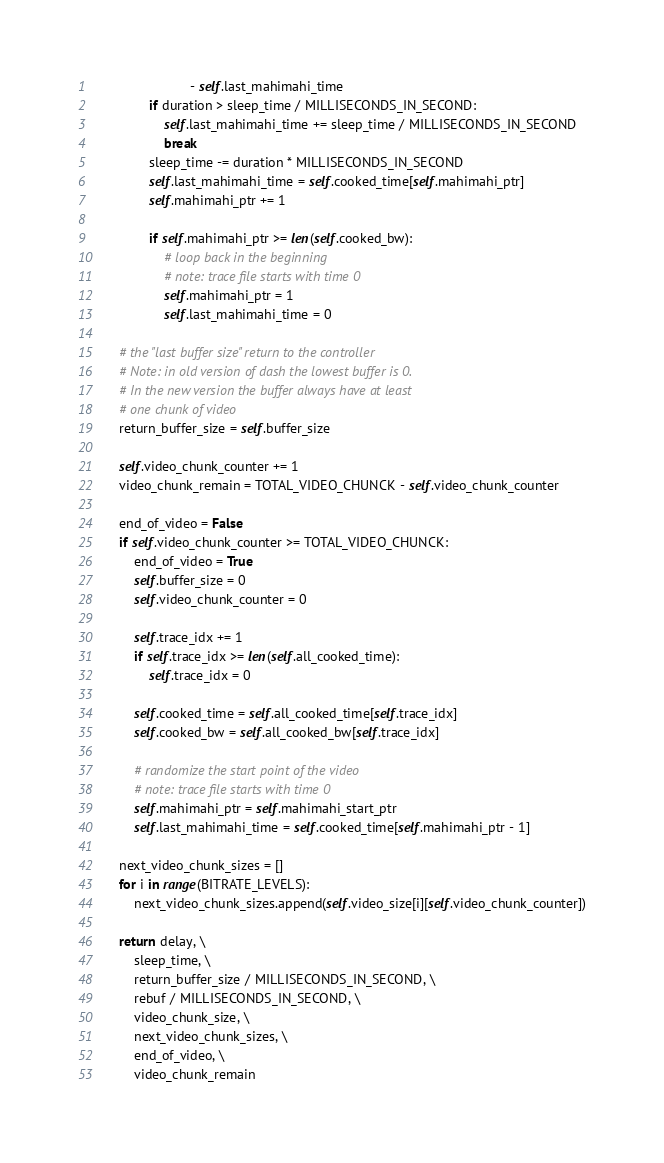Convert code to text. <code><loc_0><loc_0><loc_500><loc_500><_Python_>                           - self.last_mahimahi_time
                if duration > sleep_time / MILLISECONDS_IN_SECOND:
                    self.last_mahimahi_time += sleep_time / MILLISECONDS_IN_SECOND
                    break
                sleep_time -= duration * MILLISECONDS_IN_SECOND
                self.last_mahimahi_time = self.cooked_time[self.mahimahi_ptr]
                self.mahimahi_ptr += 1

                if self.mahimahi_ptr >= len(self.cooked_bw):
                    # loop back in the beginning
                    # note: trace file starts with time 0
                    self.mahimahi_ptr = 1
                    self.last_mahimahi_time = 0

        # the "last buffer size" return to the controller
        # Note: in old version of dash the lowest buffer is 0.
        # In the new version the buffer always have at least
        # one chunk of video
        return_buffer_size = self.buffer_size

        self.video_chunk_counter += 1
        video_chunk_remain = TOTAL_VIDEO_CHUNCK - self.video_chunk_counter

        end_of_video = False
        if self.video_chunk_counter >= TOTAL_VIDEO_CHUNCK:
            end_of_video = True
            self.buffer_size = 0
            self.video_chunk_counter = 0
            
            self.trace_idx += 1
            if self.trace_idx >= len(self.all_cooked_time):
                self.trace_idx = 0            

            self.cooked_time = self.all_cooked_time[self.trace_idx]
            self.cooked_bw = self.all_cooked_bw[self.trace_idx]

            # randomize the start point of the video
            # note: trace file starts with time 0
            self.mahimahi_ptr = self.mahimahi_start_ptr
            self.last_mahimahi_time = self.cooked_time[self.mahimahi_ptr - 1]

        next_video_chunk_sizes = []
        for i in range(BITRATE_LEVELS):
            next_video_chunk_sizes.append(self.video_size[i][self.video_chunk_counter])

        return delay, \
            sleep_time, \
            return_buffer_size / MILLISECONDS_IN_SECOND, \
            rebuf / MILLISECONDS_IN_SECOND, \
            video_chunk_size, \
            next_video_chunk_sizes, \
            end_of_video, \
            video_chunk_remain
</code> 